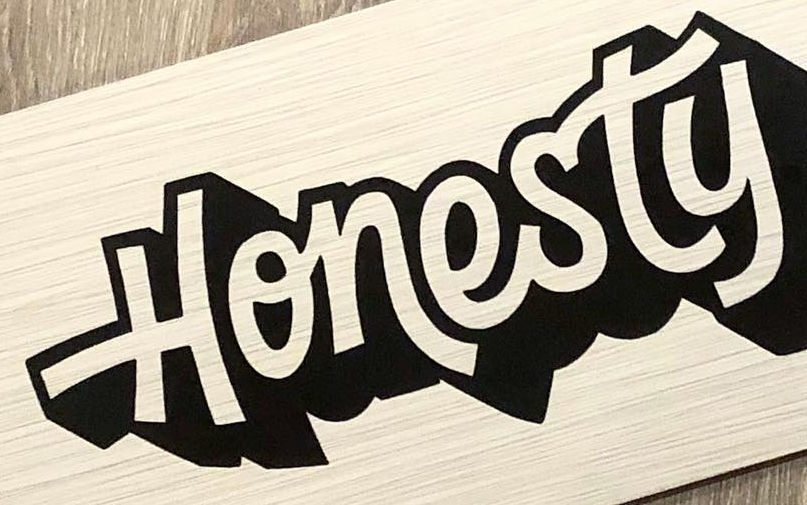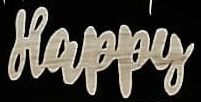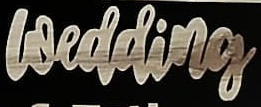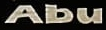What text appears in these images from left to right, separated by a semicolon? Honesty; Happy; wedding; Abu 